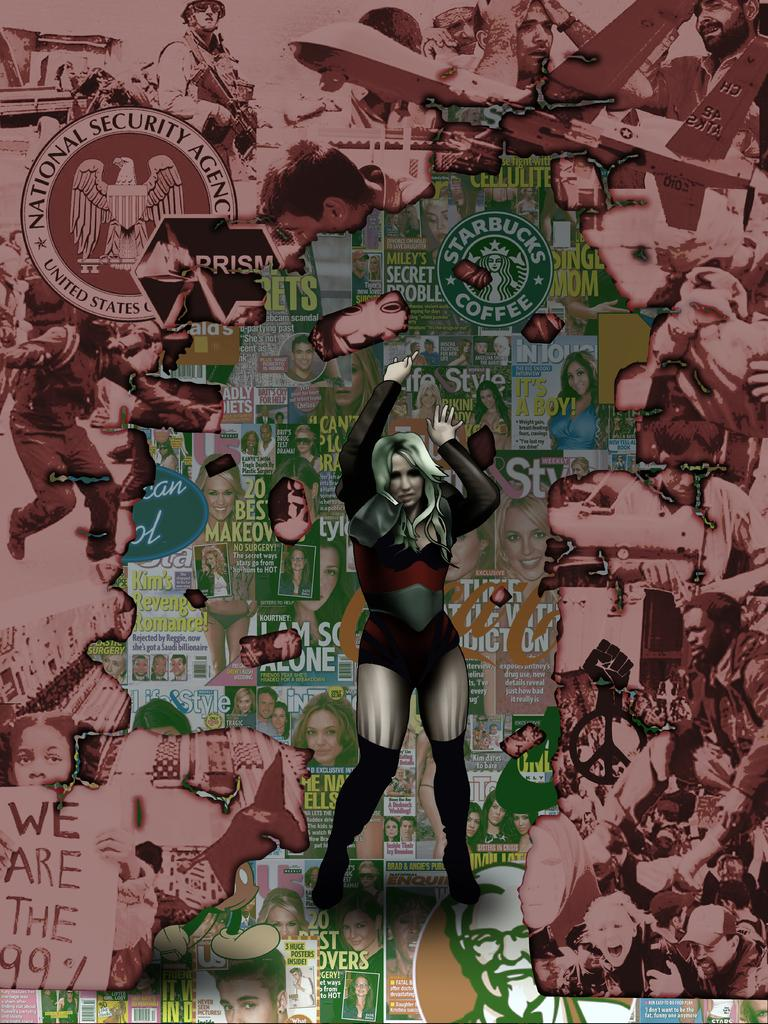<image>
Describe the image concisely. a Starbucks logo that is on the page behind a lady 